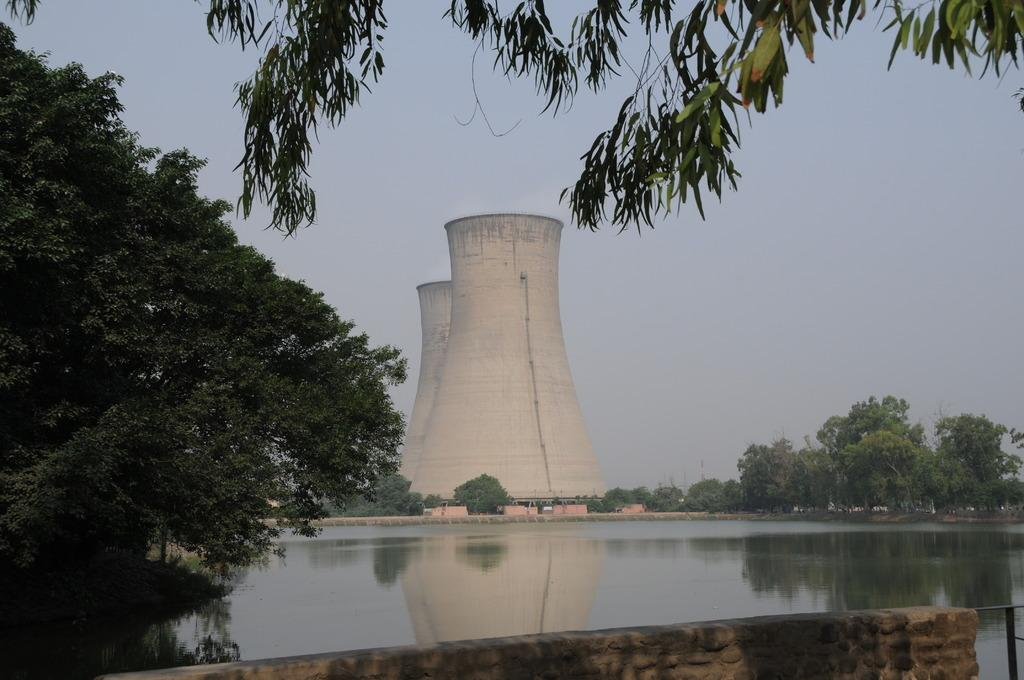What type of structure can be seen in the image? There is a stone wall in the image. What other natural elements are present in the image? There are trees and water visible in the image. What type of man-made structure is present in the image? There is a nuclear power plant in the image. What is the condition of the sky in the background? The sky in the background is plain. Where is the sofa located in the image? There is no sofa present in the image. What type of system is being used to grow the lettuce in the image? There is no lettuce or system for growing it present in the image. 